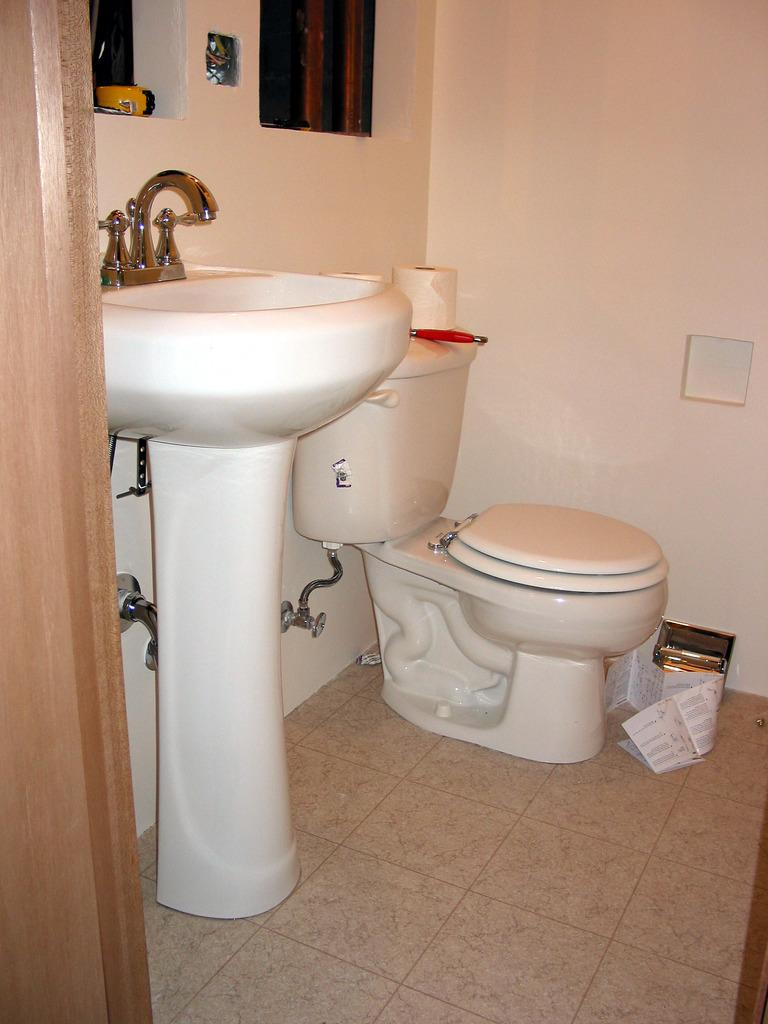What type of fixture is present in the image for washing hands or dishes? There is a sink in the image. What is used to control the flow of water in the sink? There is a tap in the image. What type of fixture is present in the image contains for sanitation purposes? There is a toilet in the image. What type of material can be seen in the image that might be used for writing or reading? There are papers visible in the image. What allows natural light to enter the room in the image? There are windows in the image. Where are the windows located in the room? The windows are on the wall. What type of twig can be seen growing out of the toilet in the image? There is no twig growing out of the toilet in the image; it is a toilet fixture for sanitation purposes. Is there a bike visible in the image? No, there is no bike present in the image. 